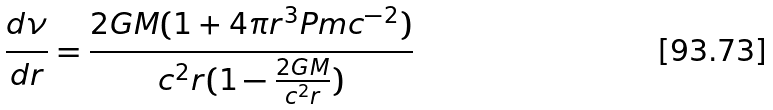Convert formula to latex. <formula><loc_0><loc_0><loc_500><loc_500>\frac { d \nu } { d r } = \frac { 2 G M ( 1 + 4 \pi { r ^ { 3 } } P m c ^ { - 2 } ) } { c ^ { 2 } r ( 1 - \frac { 2 G M } { c ^ { 2 } r } ) }</formula> 